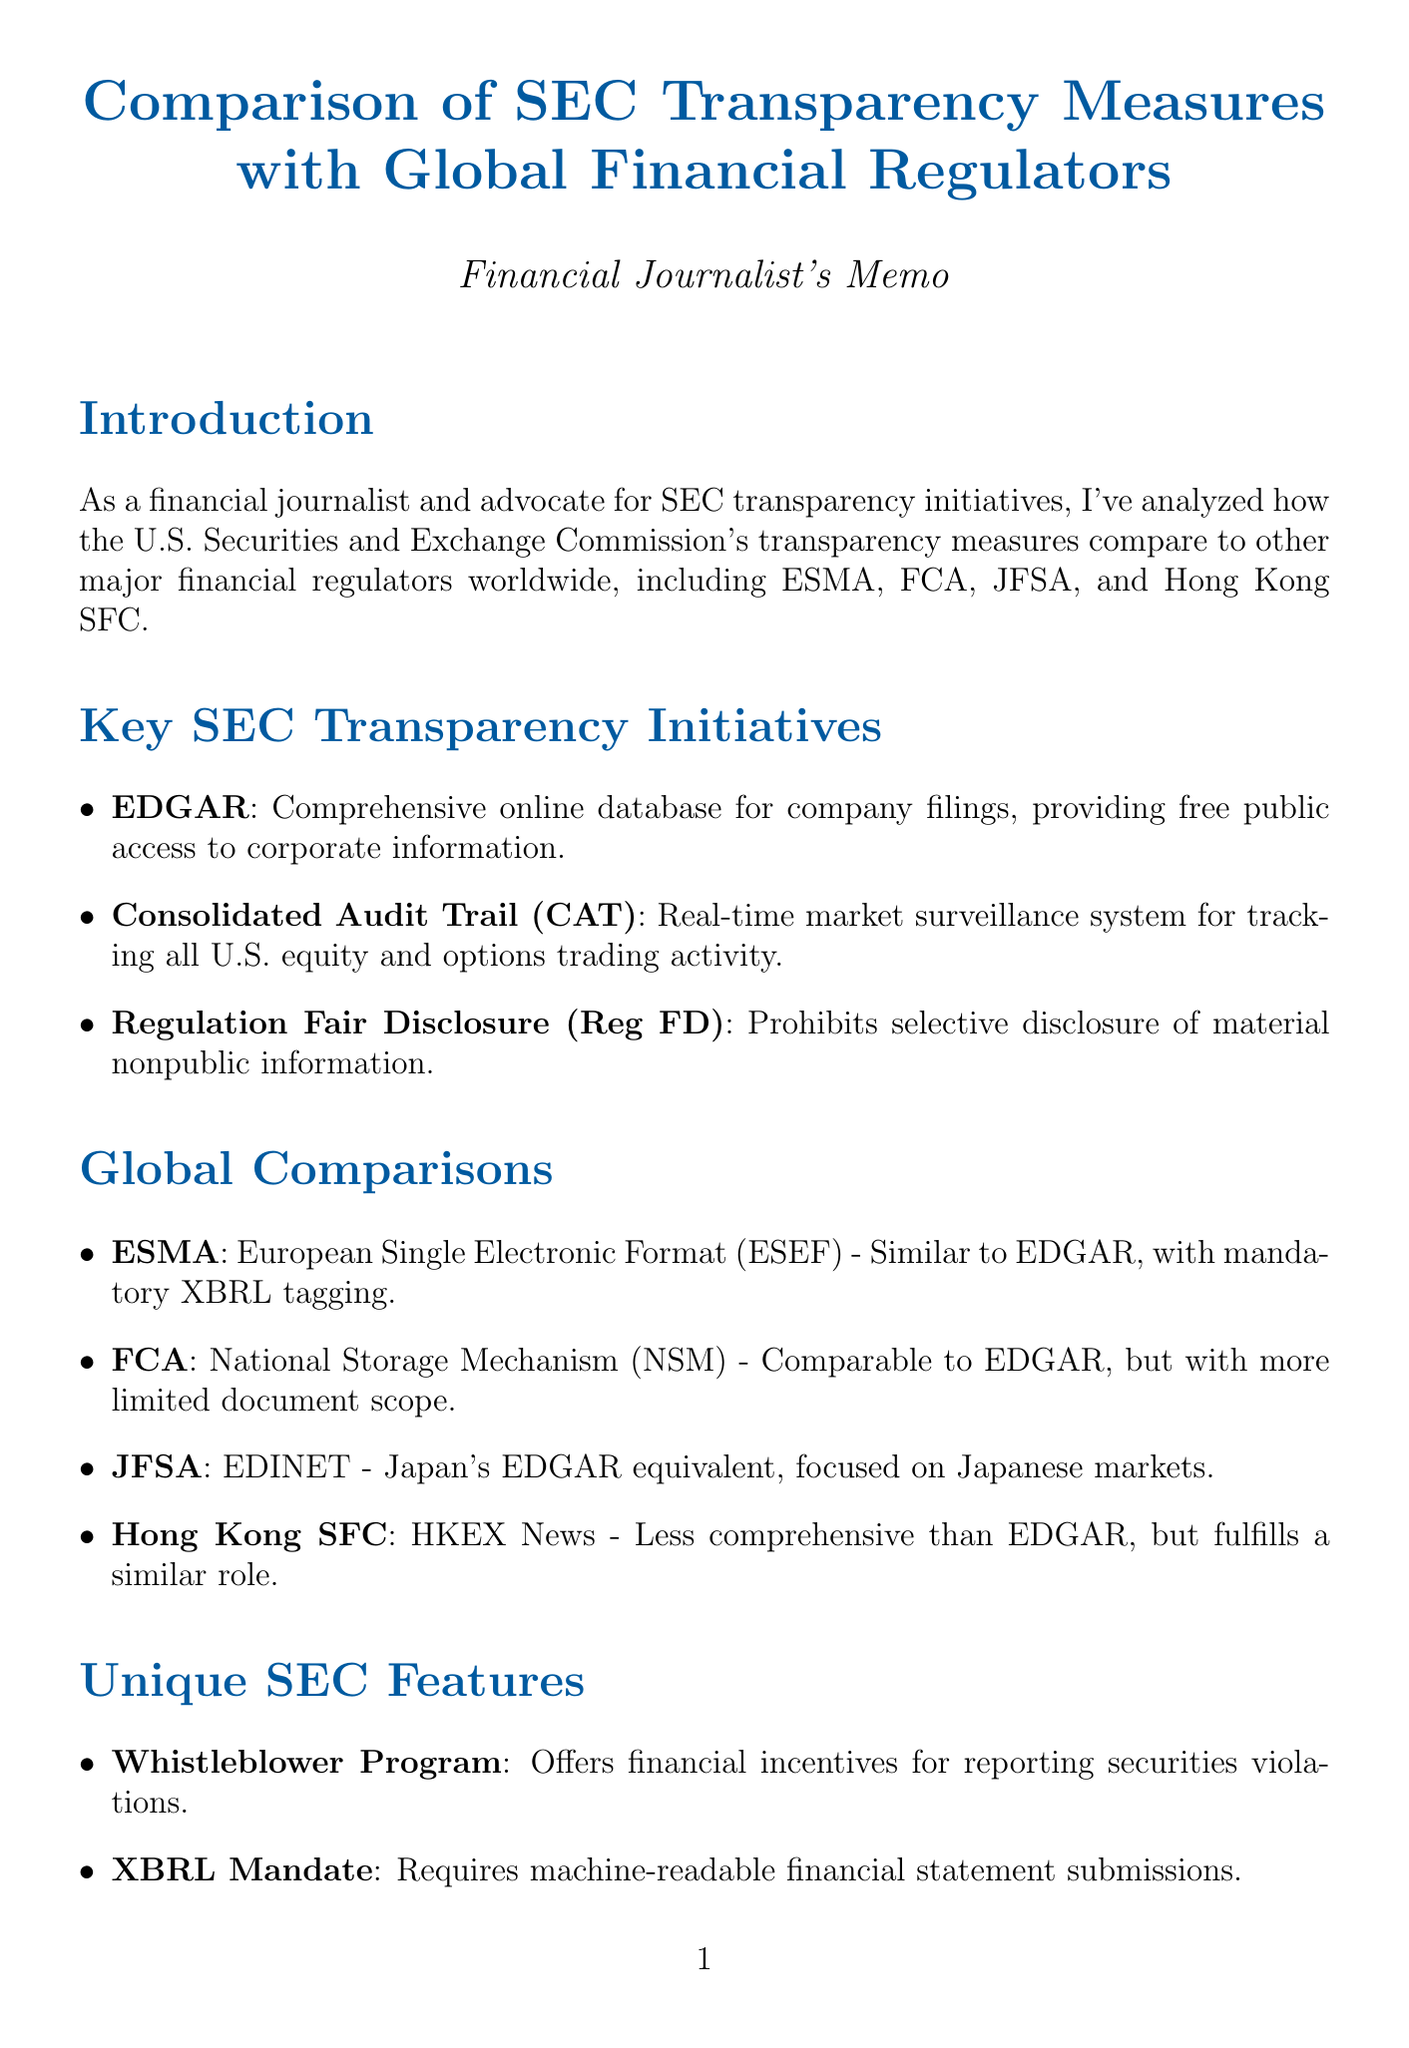what is the title of the document? The title is a key element that summarizes the main topic of the memo.
Answer: Comparison of SEC Transparency Measures with Global Financial Regulators what initiative does the SEC use for corporate filings? This initiative is a critical feature of the SEC’s transparency efforts, as indicated in the key initiatives section.
Answer: EDGAR which country’s regulator has the initiative called ESEF? This question probes the association of an initiative with its country, which is important for comparative analysis.
Answer: ESMA what unique feature includes financial incentives for reporting violations? This feature is highlighted in the unique SEC features section and underscores a specific initiative of the SEC.
Answer: Whistleblower Program how does the SEC's Consolidated Audit Trail function? This question seeks to identify the purpose of a specific initiative, requiring understanding of its impact as described in the document.
Answer: Real-time market surveillance system what is the key improvement area mentioned for the SEC? This information seeks to highlight potential developmental aspects relevant to the SEC’s global standing in the document.
Answer: Real-time disclosure which regulatory body operates the HKEX News initiative? Understanding which regulator is associated with a particular initiative helps in grasping the global context of transparency policies.
Answer: Hong Kong SFC what type of reporting format did the SEC pioneer? This question captures a specific technological advancement initiated by the SEC that is mentioned in the unique features section of the memo.
Answer: XBRL mandate how many key regulators are compared in the memo? This numerical aspect is important for understanding the scope of the analysis presented in the document.
Answer: Five 